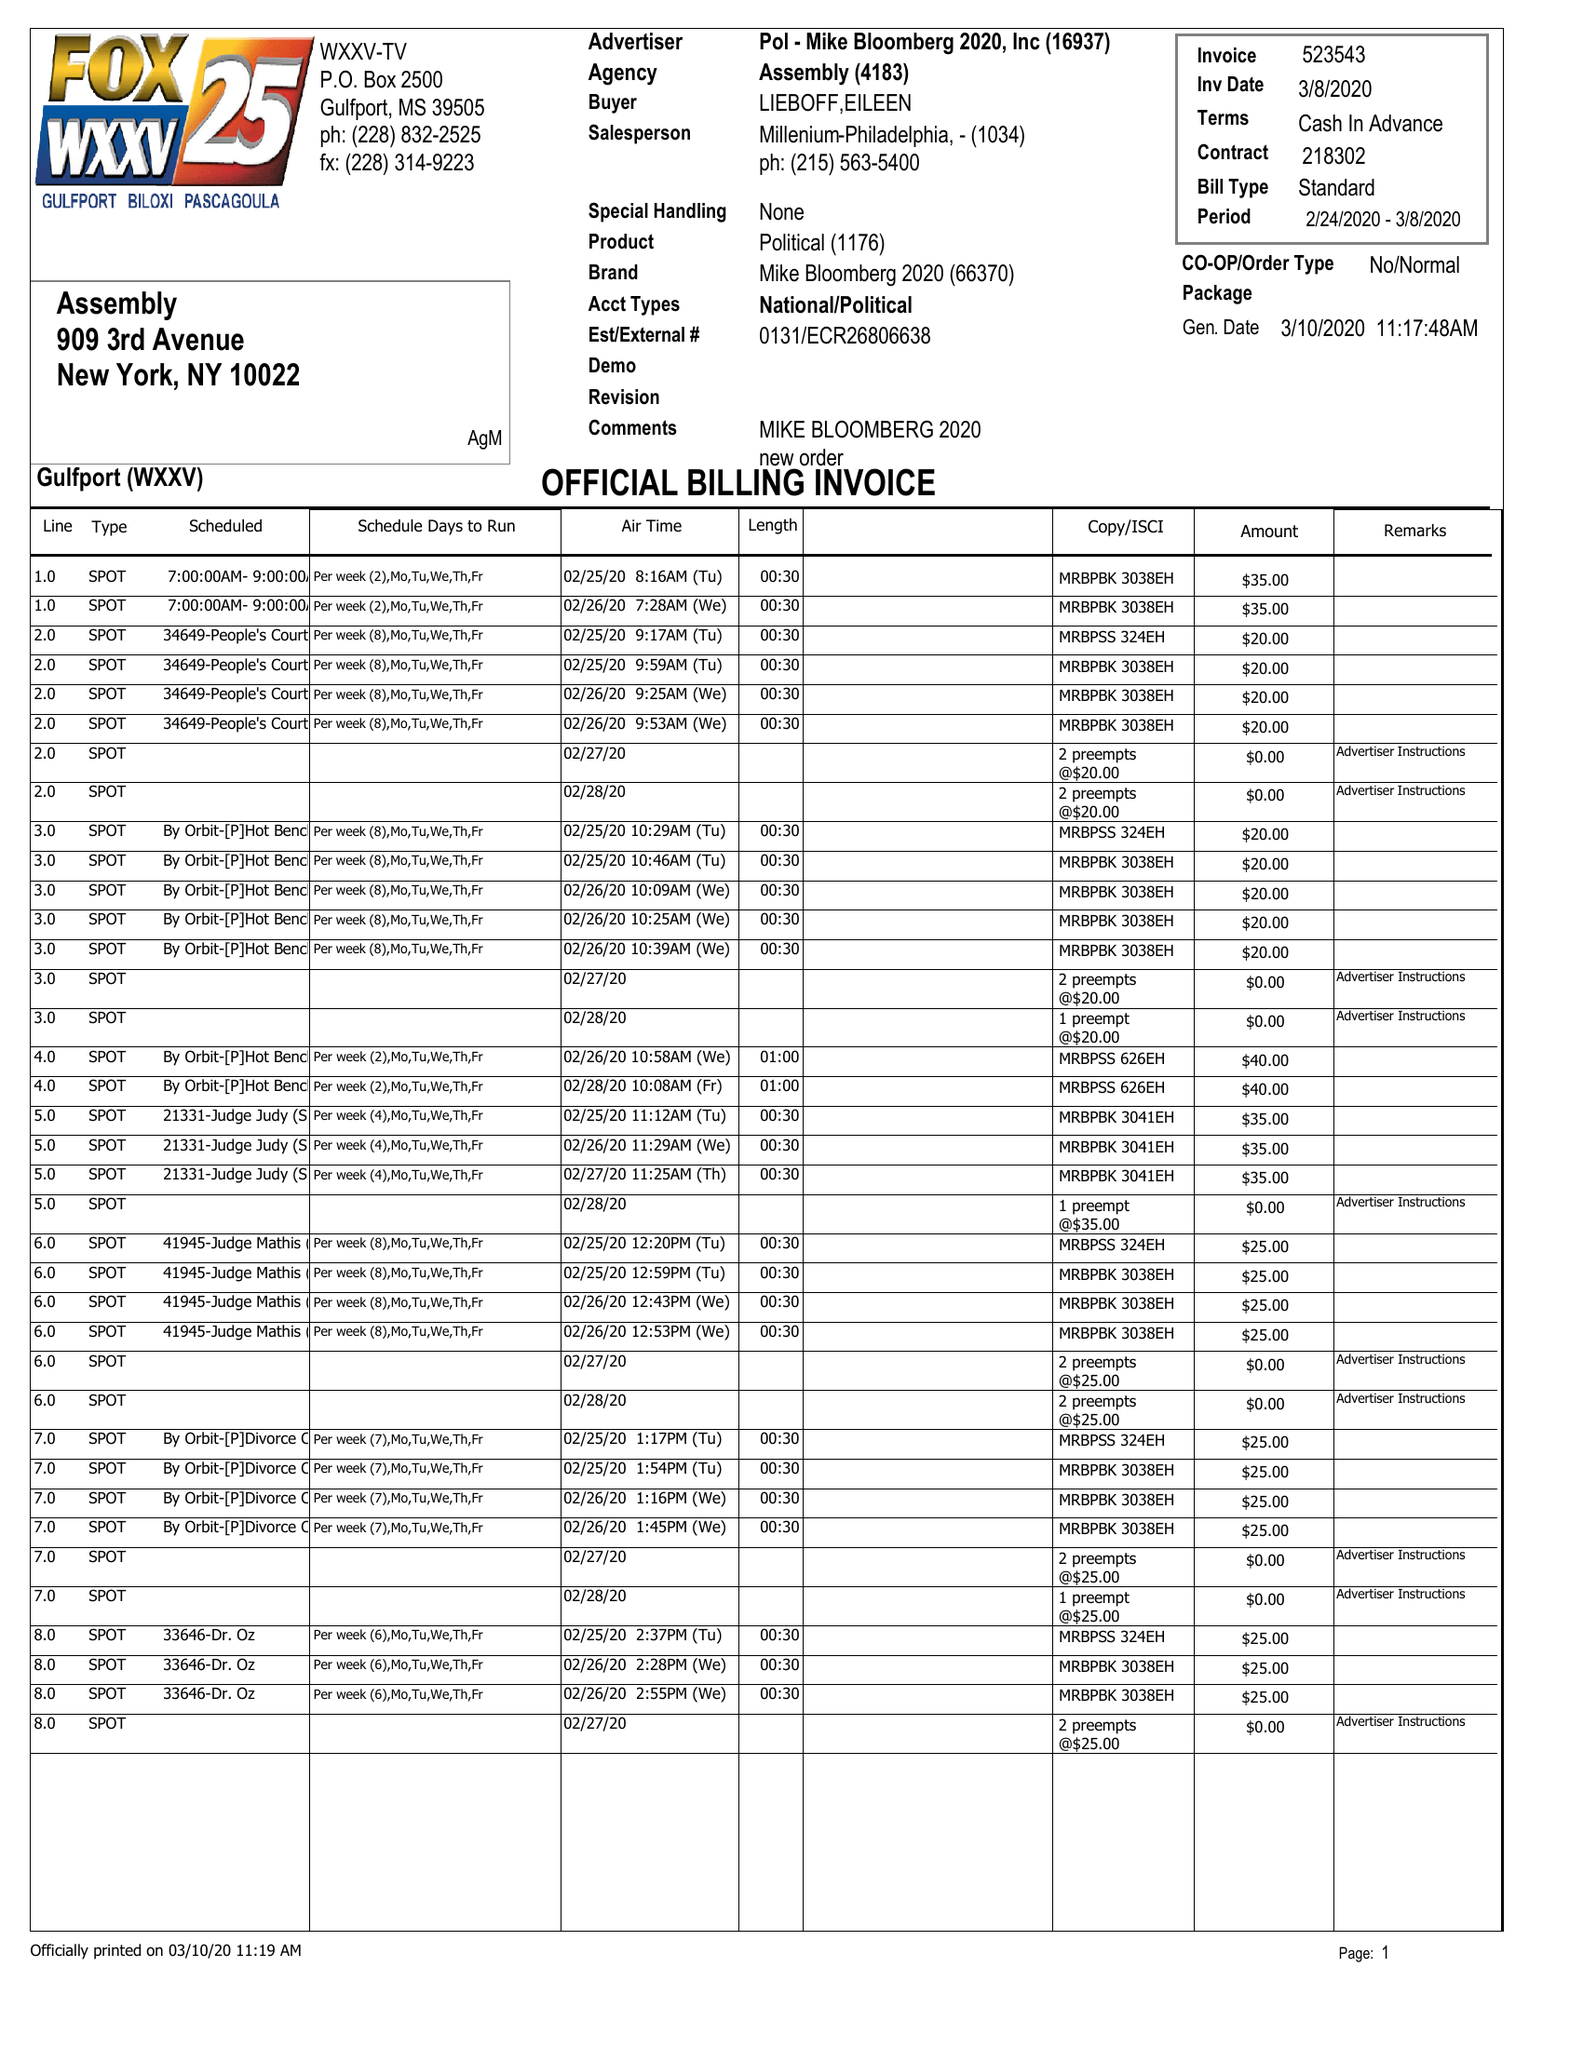What is the value for the advertiser?
Answer the question using a single word or phrase. POL - MIKE BLOOMBERG 2020, INC 